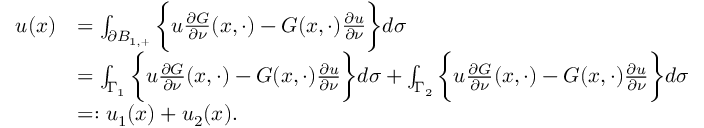Convert formula to latex. <formula><loc_0><loc_0><loc_500><loc_500>\begin{array} { r l } { u ( x ) } & { = \int _ { \partial B _ { 1 , + } } \left \{ u \frac { \partial G } { \partial \nu } ( x , \cdot ) - G ( x , \cdot ) \frac { \partial u } { \partial \nu } \right \} d \sigma } \\ & { = \int _ { \Gamma _ { 1 } } \left \{ u \frac { \partial G } { \partial \nu } ( x , \cdot ) - G ( x , \cdot ) \frac { \partial u } { \partial \nu } \right \} d \sigma + \int _ { \Gamma _ { 2 } } \left \{ u \frac { \partial G } { \partial \nu } ( x , \cdot ) - G ( x , \cdot ) \frac { \partial u } { \partial \nu } \right \} d \sigma } \\ & { = \colon u _ { 1 } ( x ) + u _ { 2 } ( x ) . } \end{array}</formula> 